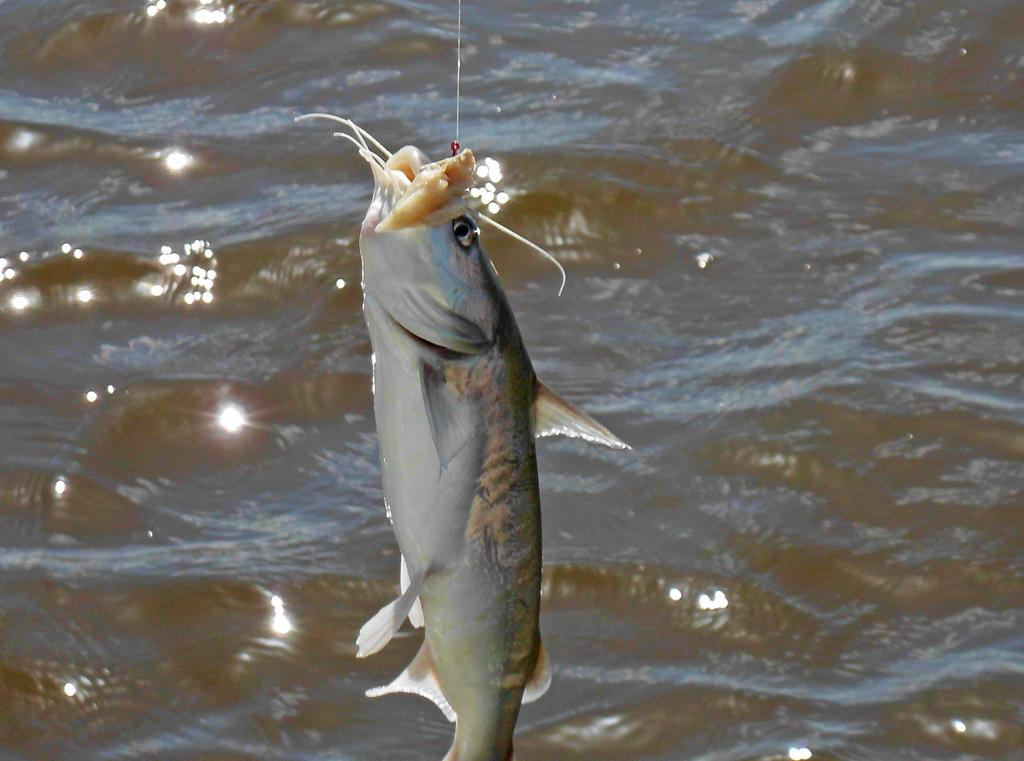What type of animal is in the image? There is a fish in the image. What is the fish's position in relation to the wire? The fish is stuck to a wire. What can be seen in the background of the image? There is water visible in the background of the image. Are there any men holding snakes in the image? There are no men or snakes present in the image; it features a fish stuck to a wire with water visible in the background. 